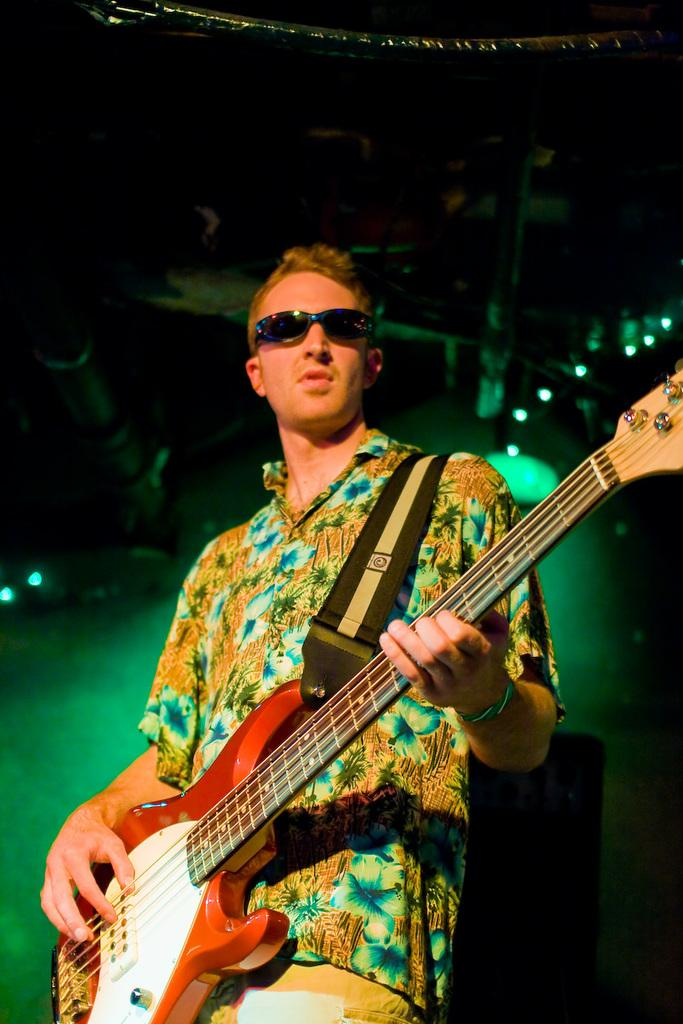What is the person in the image doing? The person is playing a guitar. Can you describe the person's appearance? The person is wearing glasses. What else can be seen in the image? There are lights visible at the top of the image. What type of slope can be seen in the image? There is no slope present in the image. What is the person's occupation, as depicted in the image? The image does not provide information about the person's occupation. 